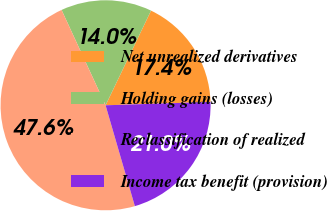Convert chart. <chart><loc_0><loc_0><loc_500><loc_500><pie_chart><fcel>Net unrealized derivatives<fcel>Holding gains (losses)<fcel>Reclassification of realized<fcel>Income tax benefit (provision)<nl><fcel>17.37%<fcel>14.01%<fcel>47.62%<fcel>21.01%<nl></chart> 